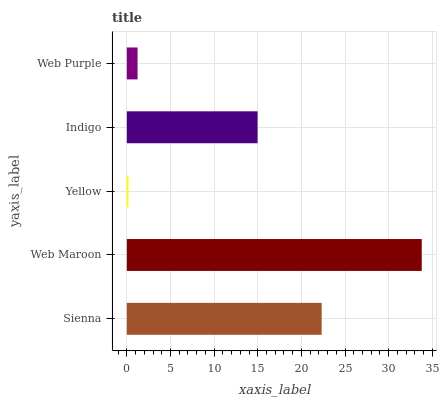Is Yellow the minimum?
Answer yes or no. Yes. Is Web Maroon the maximum?
Answer yes or no. Yes. Is Web Maroon the minimum?
Answer yes or no. No. Is Yellow the maximum?
Answer yes or no. No. Is Web Maroon greater than Yellow?
Answer yes or no. Yes. Is Yellow less than Web Maroon?
Answer yes or no. Yes. Is Yellow greater than Web Maroon?
Answer yes or no. No. Is Web Maroon less than Yellow?
Answer yes or no. No. Is Indigo the high median?
Answer yes or no. Yes. Is Indigo the low median?
Answer yes or no. Yes. Is Web Maroon the high median?
Answer yes or no. No. Is Sienna the low median?
Answer yes or no. No. 